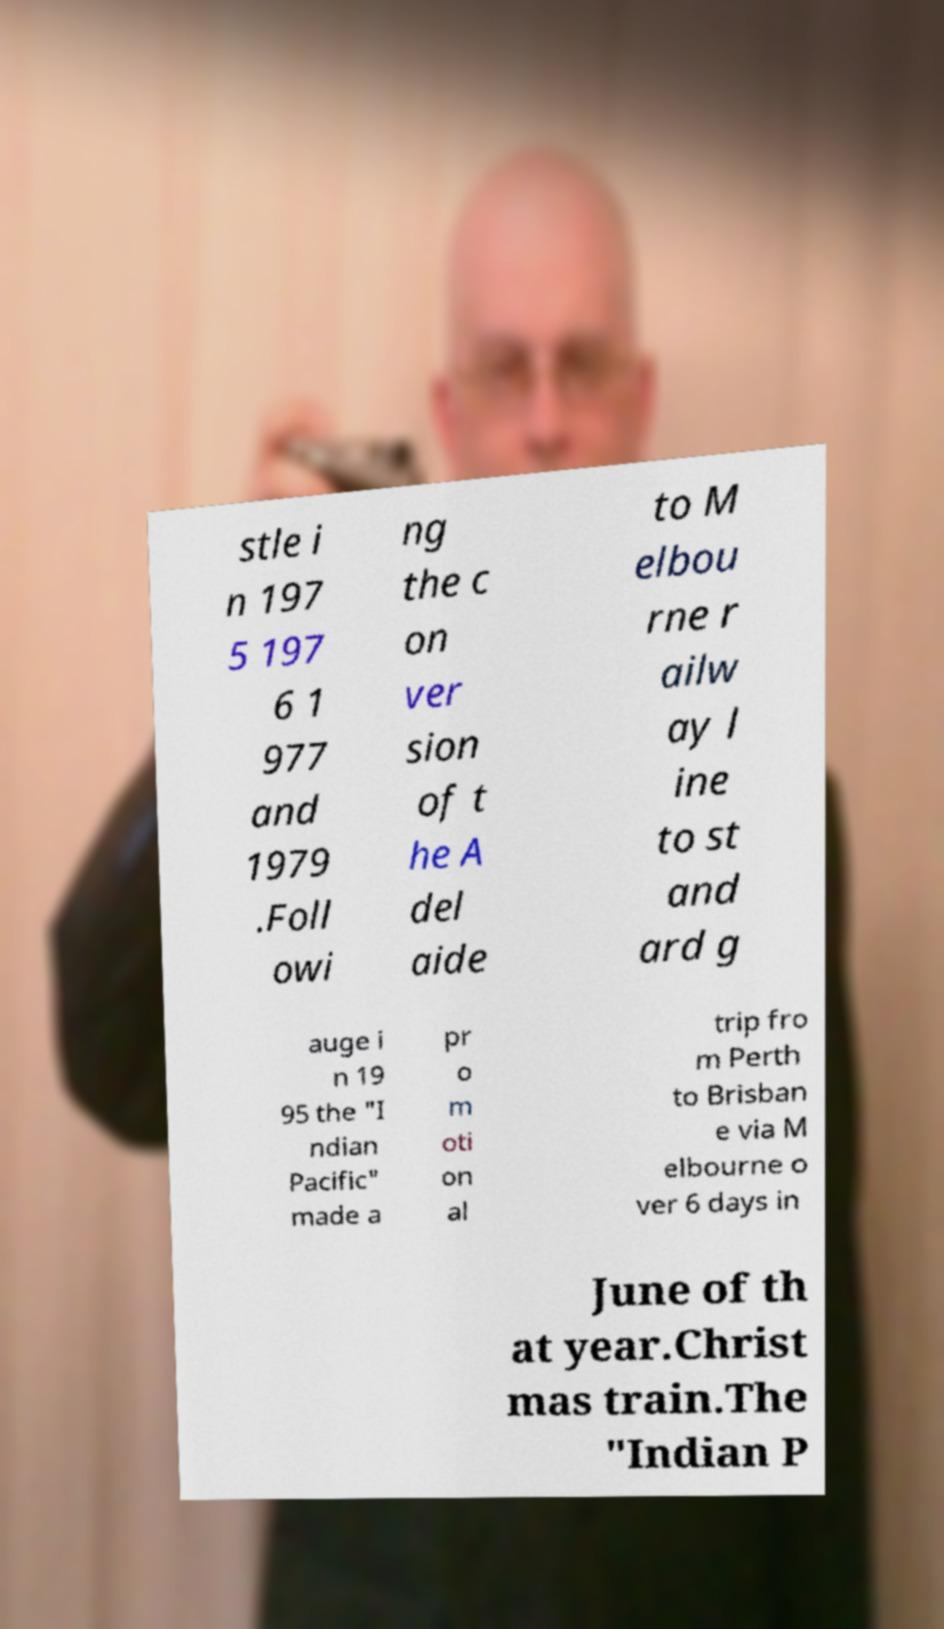Can you accurately transcribe the text from the provided image for me? stle i n 197 5 197 6 1 977 and 1979 .Foll owi ng the c on ver sion of t he A del aide to M elbou rne r ailw ay l ine to st and ard g auge i n 19 95 the "I ndian Pacific" made a pr o m oti on al trip fro m Perth to Brisban e via M elbourne o ver 6 days in June of th at year.Christ mas train.The "Indian P 